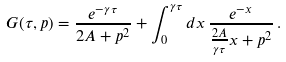Convert formula to latex. <formula><loc_0><loc_0><loc_500><loc_500>G ( \tau , p ) = \frac { e ^ { - \gamma \tau } } { 2 A + p ^ { 2 } } + \int _ { 0 } ^ { \gamma \tau } d x \, \frac { e ^ { - x } } { \frac { 2 A } { \gamma \tau } x + p ^ { 2 } } \, .</formula> 